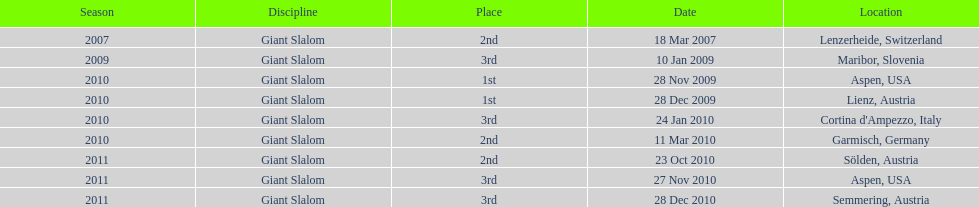Where was her first win? Aspen, USA. 